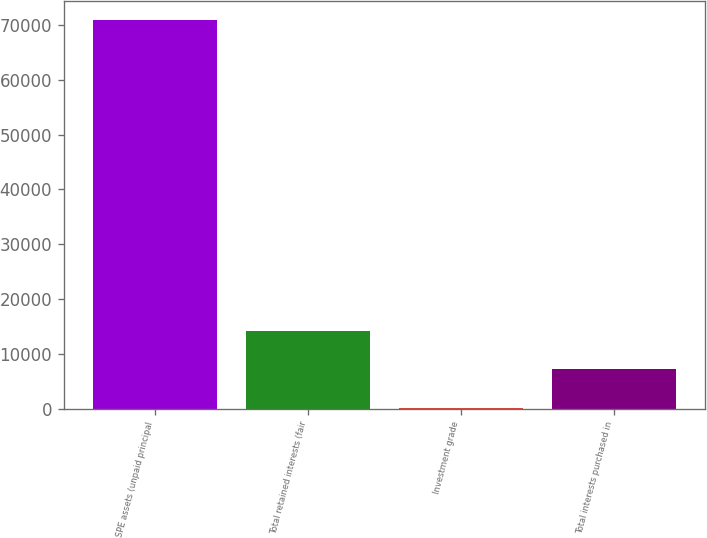<chart> <loc_0><loc_0><loc_500><loc_500><bar_chart><fcel>SPE assets (unpaid principal<fcel>Total retained interests (fair<fcel>Investment grade<fcel>Total interests purchased in<nl><fcel>70824<fcel>14264<fcel>124<fcel>7194<nl></chart> 